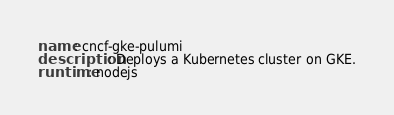Convert code to text. <code><loc_0><loc_0><loc_500><loc_500><_YAML_>name: cncf-gke-pulumi
description: Deploys a Kubernetes cluster on GKE.
runtime: nodejs
</code> 